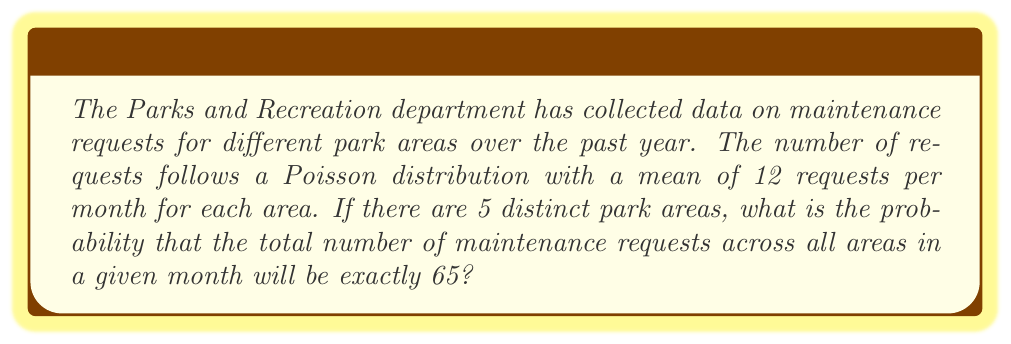Provide a solution to this math problem. Let's approach this step-by-step:

1) Each park area follows a Poisson distribution with mean $\lambda = 12$ requests per month.

2) There are 5 distinct park areas, so we need to consider the sum of 5 independent Poisson distributions.

3) A key property of Poisson distributions is that the sum of independent Poisson variables is also Poisson distributed. The mean of the sum is the sum of the individual means.

4) So, the total number of requests across all 5 areas follows a Poisson distribution with mean:
   
   $\lambda_{total} = 5 \times 12 = 60$ requests per month

5) We want to find $P(X = 65)$ where $X \sim Poisson(60)$

6) The probability mass function for a Poisson distribution is:

   $P(X = k) = \frac{e^{-\lambda} \lambda^k}{k!}$

7) Substituting our values:

   $P(X = 65) = \frac{e^{-60} 60^{65}}{65!}$

8) This can be calculated using a scientific calculator or programming language:

   $P(X = 65) \approx 0.0449$

Therefore, the probability of exactly 65 maintenance requests across all areas in a given month is approximately 0.0449 or 4.49%.
Answer: 0.0449 